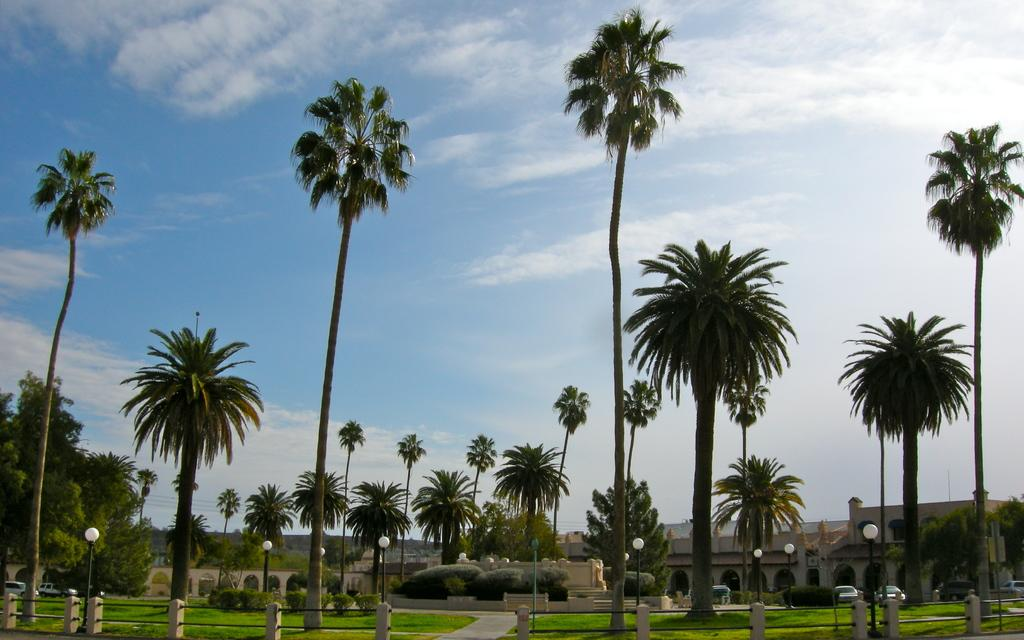What type of vegetation can be seen in the image? There are trees in the image. What structures are present in the image? There are fences, light poles, vehicles, and buildings in the image. What type of ground surface is visible in the image? There is grass in the image. What can be seen in the background of the image? The sky with clouds is visible in the background of the image. What type of paper is being used to write on the quill in the image? There is no paper or quill present in the image. How many pears are visible on the trees in the image? There are no pears visible in the image; only trees, fences, light poles, vehicles, buildings, grass, and the sky with clouds are present. 